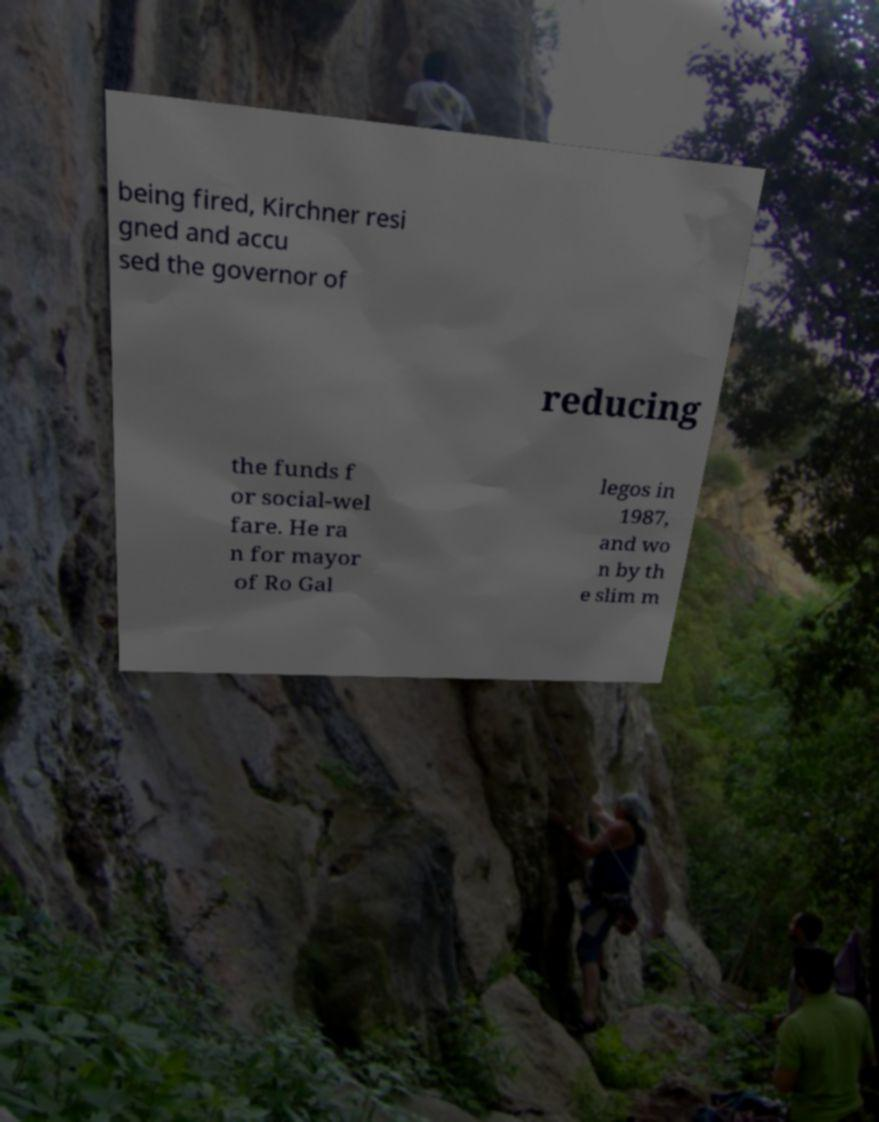For documentation purposes, I need the text within this image transcribed. Could you provide that? being fired, Kirchner resi gned and accu sed the governor of reducing the funds f or social-wel fare. He ra n for mayor of Ro Gal legos in 1987, and wo n by th e slim m 